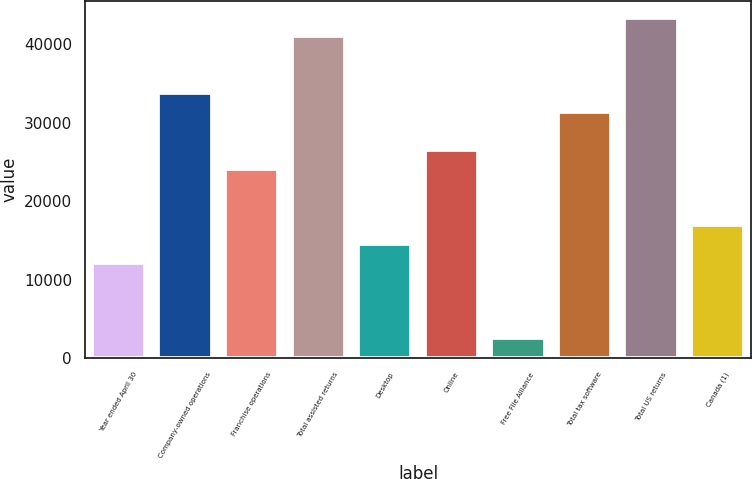Convert chart to OTSL. <chart><loc_0><loc_0><loc_500><loc_500><bar_chart><fcel>Year ended April 30<fcel>Company-owned operations<fcel>Franchise operations<fcel>Total assisted returns<fcel>Desktop<fcel>Online<fcel>Free File Alliance<fcel>Total tax software<fcel>Total US returns<fcel>Canada (1)<nl><fcel>12140<fcel>33785<fcel>24165<fcel>41000<fcel>14545<fcel>26570<fcel>2520<fcel>31380<fcel>43405<fcel>16950<nl></chart> 